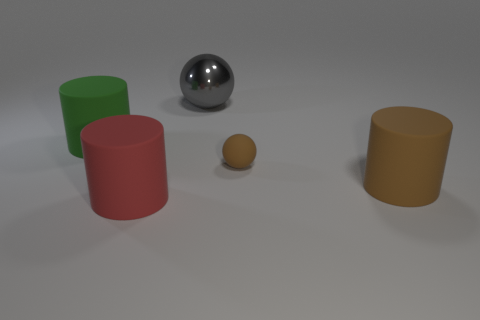Add 3 big brown rubber balls. How many objects exist? 8 Subtract 1 spheres. How many spheres are left? 1 Subtract all brown spheres. How many spheres are left? 1 Subtract all cylinders. How many objects are left? 2 Subtract all gray cylinders. Subtract all brown spheres. How many cylinders are left? 3 Subtract all cyan spheres. How many yellow cylinders are left? 0 Subtract all brown shiny objects. Subtract all large red cylinders. How many objects are left? 4 Add 2 red matte objects. How many red matte objects are left? 3 Add 2 red things. How many red things exist? 3 Subtract 0 red blocks. How many objects are left? 5 